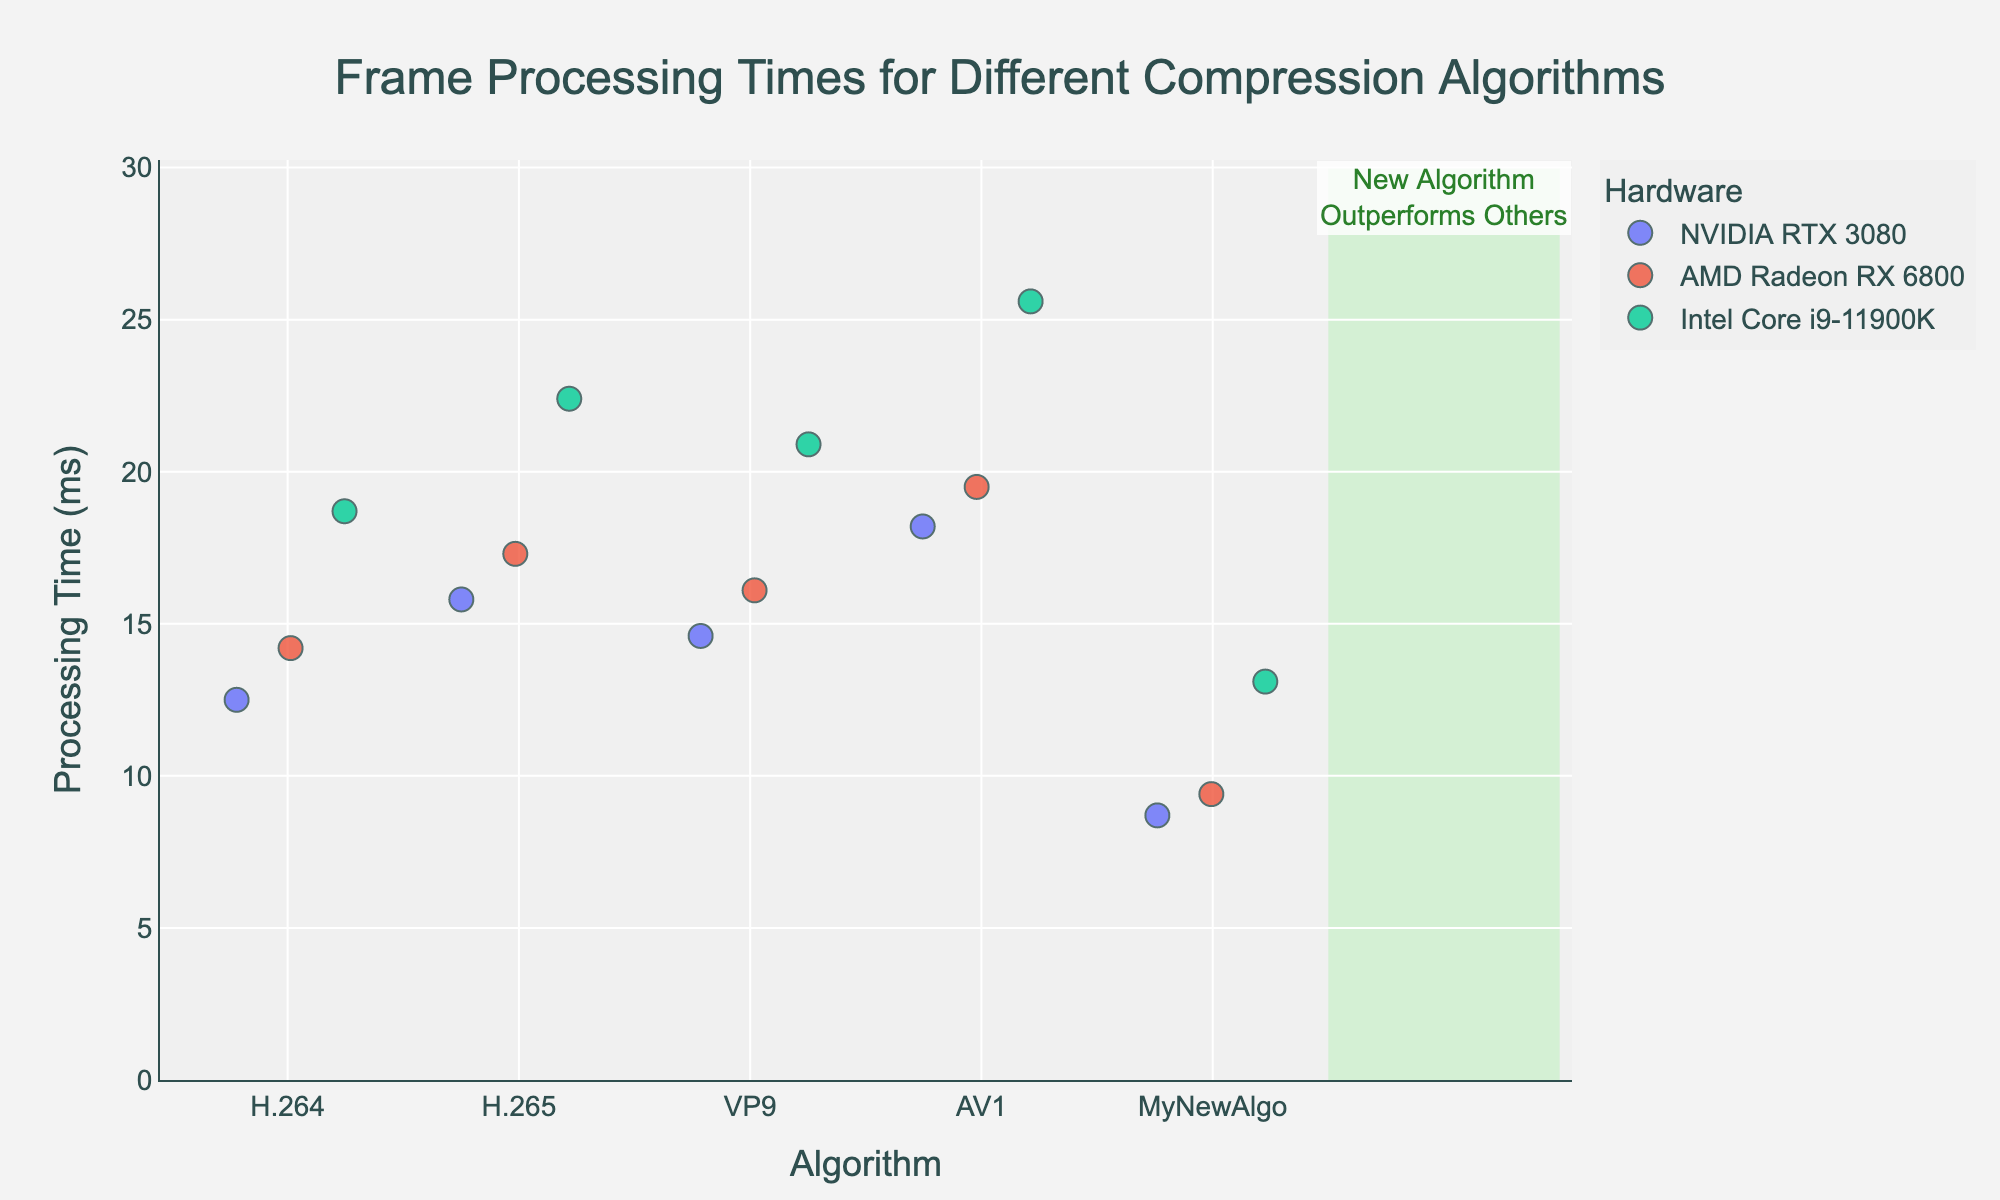What is the title of the plot? The title usually appears at the top of the plot. It summarizes the content or purpose of the plot. In this case, we can see the title displayed prominently at the top.
Answer: "Frame Processing Times for Different Compression Algorithms" Which algorithm has the lowest frame processing time on NVIDIA RTX 3080? To determine this, look at the position of the data points along the y-axis for NVIDIA RTX 3080 under each algorithm category and identify the lowest point. "MyNewAlgo" has a point at 8.7 ms, which is lower than all other points.
Answer: MyNewAlgo What is the maximum processing time for H.265 across all hardware configurations? Check the vertical positions of the points in the H.265 category on the strip plot. The highest point represents the maximum time, which is around 22.4 ms for Intel Core i9-11900K.
Answer: 22.4 ms How does the processing time of H.264 on AMD Radeon RX 6800 compare to H.265 on the same hardware? Locate the points for AMD Radeon RX 6800 in both H.264 and H.265 categories and compare their y-axis values. H.264 is at 14.2 ms, and H.265 is at 17.3 ms. H.264 is faster.
Answer: H.264 is faster Among all algorithms, which one performs consistently fastest across different hardware configurations? Look for the algorithm with the lowest spread (lowest median position) across the three hardware configurations. "MyNewAlgo" consistently shows lower processing times compared to other algorithms.
Answer: MyNewAlgo How many algorithms show at least one processing time below 15 ms? Count the categories where one or more data points are positioned below the 15 ms mark on the y-axis. H.264, H.265, VP9, and MyNewAlgo all have points below 15 ms.
Answer: Four algorithms What is the range of processing times for the AV1 algorithm? Identify the highest and lowest points within the AV1 category, then subtract the lowest from the highest. The range is from 18.2 ms to 25.6 ms.
Answer: 7.4 ms What is the median processing time of MyNewAlgo across all hardware? Find the middle value of the sorted set of times {8.7, 9.4, 13.1} for MyNewAlgo. Since there are three points, the median is the middle value.
Answer: 9.4 ms Which hardware shows the highest processing time variance across different algorithms? Observe the spread of data points for each hardware. Intel Core i9-11900K has a wide spread of times ranging roughly from 13.1 ms up to 25.6 ms, indicating high variance.
Answer: Intel Core i9-11900K 